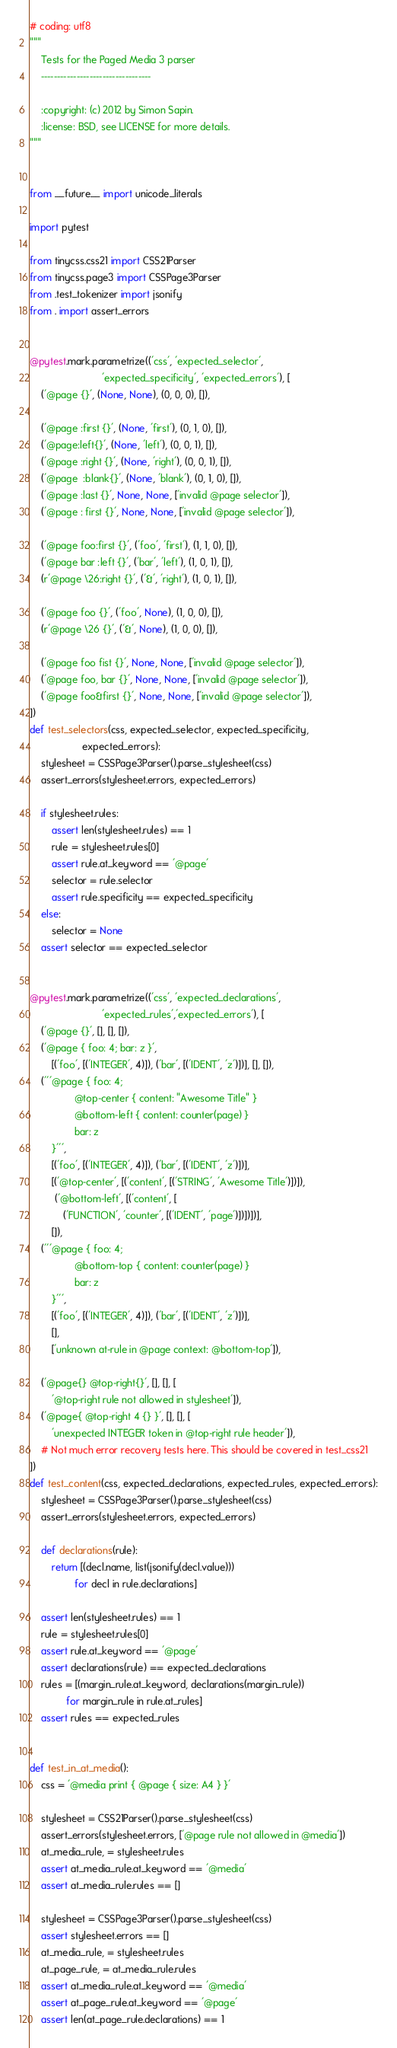<code> <loc_0><loc_0><loc_500><loc_500><_Python_># coding: utf8
"""
    Tests for the Paged Media 3 parser
    ----------------------------------

    :copyright: (c) 2012 by Simon Sapin.
    :license: BSD, see LICENSE for more details.
"""


from __future__ import unicode_literals

import pytest

from tinycss.css21 import CSS21Parser
from tinycss.page3 import CSSPage3Parser
from .test_tokenizer import jsonify
from . import assert_errors


@pytest.mark.parametrize(('css', 'expected_selector',
                          'expected_specificity', 'expected_errors'), [
    ('@page {}', (None, None), (0, 0, 0), []),

    ('@page :first {}', (None, 'first'), (0, 1, 0), []),
    ('@page:left{}', (None, 'left'), (0, 0, 1), []),
    ('@page :right {}', (None, 'right'), (0, 0, 1), []),
    ('@page  :blank{}', (None, 'blank'), (0, 1, 0), []),
    ('@page :last {}', None, None, ['invalid @page selector']),
    ('@page : first {}', None, None, ['invalid @page selector']),

    ('@page foo:first {}', ('foo', 'first'), (1, 1, 0), []),
    ('@page bar :left {}', ('bar', 'left'), (1, 0, 1), []),
    (r'@page \26:right {}', ('&', 'right'), (1, 0, 1), []),

    ('@page foo {}', ('foo', None), (1, 0, 0), []),
    (r'@page \26 {}', ('&', None), (1, 0, 0), []),

    ('@page foo fist {}', None, None, ['invalid @page selector']),
    ('@page foo, bar {}', None, None, ['invalid @page selector']),
    ('@page foo&first {}', None, None, ['invalid @page selector']),
])
def test_selectors(css, expected_selector, expected_specificity,
                   expected_errors):
    stylesheet = CSSPage3Parser().parse_stylesheet(css)
    assert_errors(stylesheet.errors, expected_errors)

    if stylesheet.rules:
        assert len(stylesheet.rules) == 1
        rule = stylesheet.rules[0]
        assert rule.at_keyword == '@page'
        selector = rule.selector
        assert rule.specificity == expected_specificity
    else:
        selector = None
    assert selector == expected_selector


@pytest.mark.parametrize(('css', 'expected_declarations',
                          'expected_rules','expected_errors'), [
    ('@page {}', [], [], []),
    ('@page { foo: 4; bar: z }',
        [('foo', [('INTEGER', 4)]), ('bar', [('IDENT', 'z')])], [], []),
    ('''@page { foo: 4;
                @top-center { content: "Awesome Title" }
                @bottom-left { content: counter(page) }
                bar: z
        }''',
        [('foo', [('INTEGER', 4)]), ('bar', [('IDENT', 'z')])],
        [('@top-center', [('content', [('STRING', 'Awesome Title')])]),
         ('@bottom-left', [('content', [
            ('FUNCTION', 'counter', [('IDENT', 'page')])])])],
        []),
    ('''@page { foo: 4;
                @bottom-top { content: counter(page) }
                bar: z
        }''',
        [('foo', [('INTEGER', 4)]), ('bar', [('IDENT', 'z')])],
        [],
        ['unknown at-rule in @page context: @bottom-top']),

    ('@page{} @top-right{}', [], [], [
        '@top-right rule not allowed in stylesheet']),
    ('@page{ @top-right 4 {} }', [], [], [
        'unexpected INTEGER token in @top-right rule header']),
    # Not much error recovery tests here. This should be covered in test_css21
])
def test_content(css, expected_declarations, expected_rules, expected_errors):
    stylesheet = CSSPage3Parser().parse_stylesheet(css)
    assert_errors(stylesheet.errors, expected_errors)

    def declarations(rule):
        return [(decl.name, list(jsonify(decl.value)))
                for decl in rule.declarations]

    assert len(stylesheet.rules) == 1
    rule = stylesheet.rules[0]
    assert rule.at_keyword == '@page'
    assert declarations(rule) == expected_declarations
    rules = [(margin_rule.at_keyword, declarations(margin_rule))
             for margin_rule in rule.at_rules]
    assert rules == expected_rules


def test_in_at_media():
    css = '@media print { @page { size: A4 } }'

    stylesheet = CSS21Parser().parse_stylesheet(css)
    assert_errors(stylesheet.errors, ['@page rule not allowed in @media'])
    at_media_rule, = stylesheet.rules
    assert at_media_rule.at_keyword == '@media'
    assert at_media_rule.rules == []

    stylesheet = CSSPage3Parser().parse_stylesheet(css)
    assert stylesheet.errors == []
    at_media_rule, = stylesheet.rules
    at_page_rule, = at_media_rule.rules
    assert at_media_rule.at_keyword == '@media'
    assert at_page_rule.at_keyword == '@page'
    assert len(at_page_rule.declarations) == 1
</code> 